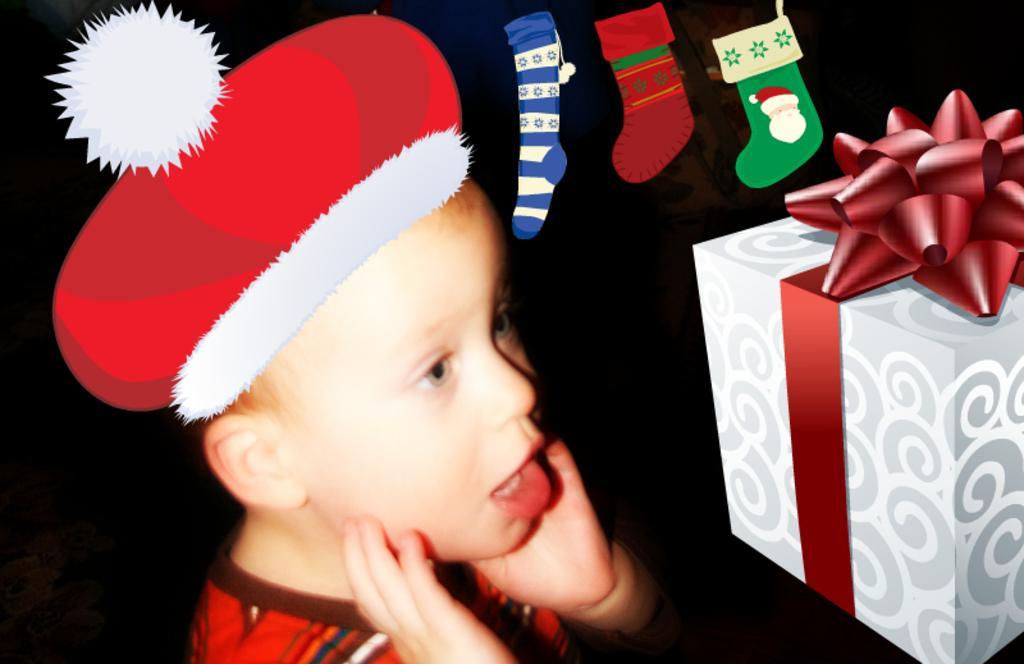In one or two sentences, can you explain what this image depicts? This image is animated and real image in which there is a boy and there are animations of box, socks and hat. 